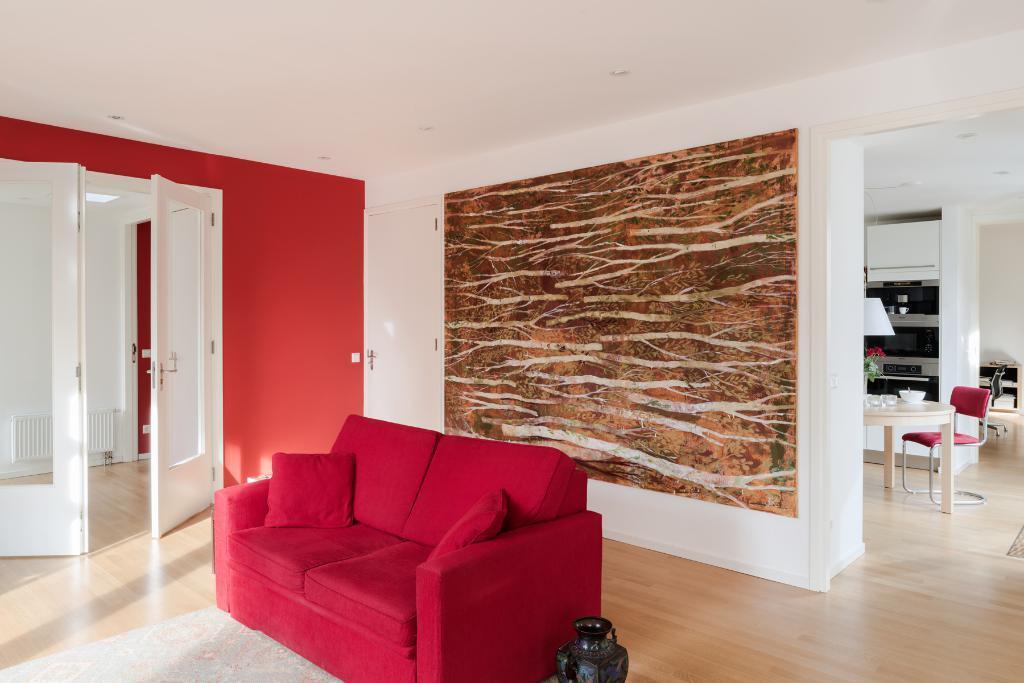Could you give a brief overview of what you see in this image? In this image I see a red couch over here and there is a door and a vase. In the background I see the wall, a chair near the table and few things on it and few equipment over here. 